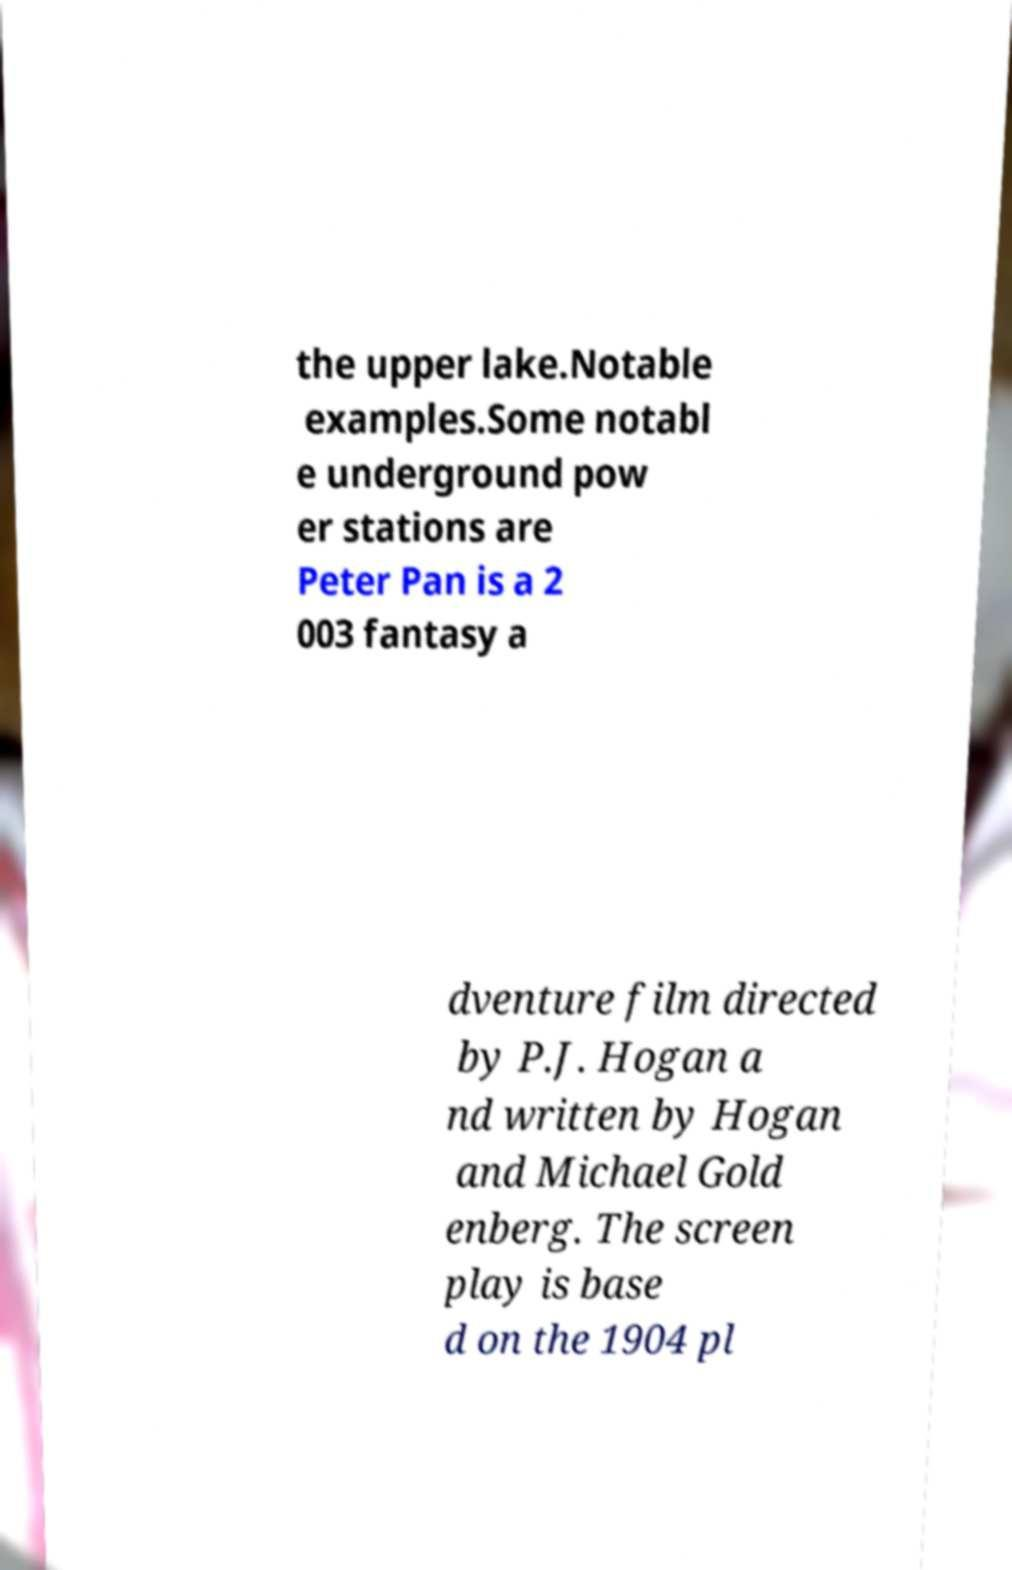For documentation purposes, I need the text within this image transcribed. Could you provide that? the upper lake.Notable examples.Some notabl e underground pow er stations are Peter Pan is a 2 003 fantasy a dventure film directed by P.J. Hogan a nd written by Hogan and Michael Gold enberg. The screen play is base d on the 1904 pl 